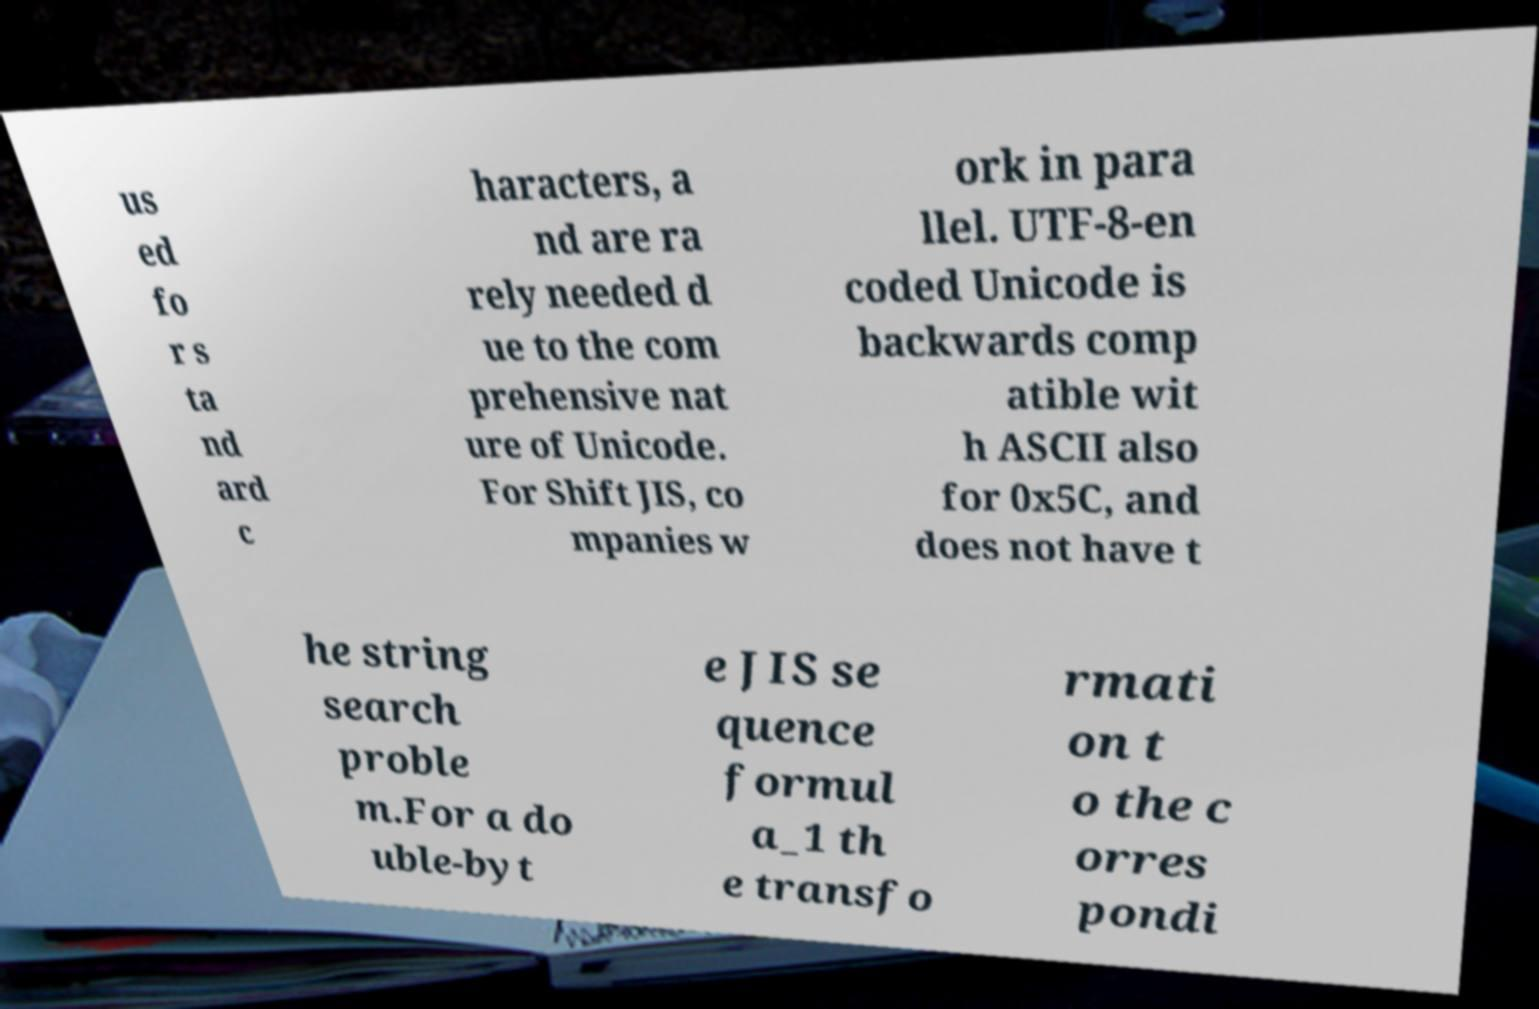Please identify and transcribe the text found in this image. us ed fo r s ta nd ard c haracters, a nd are ra rely needed d ue to the com prehensive nat ure of Unicode. For Shift JIS, co mpanies w ork in para llel. UTF-8-en coded Unicode is backwards comp atible wit h ASCII also for 0x5C, and does not have t he string search proble m.For a do uble-byt e JIS se quence formul a_1 th e transfo rmati on t o the c orres pondi 